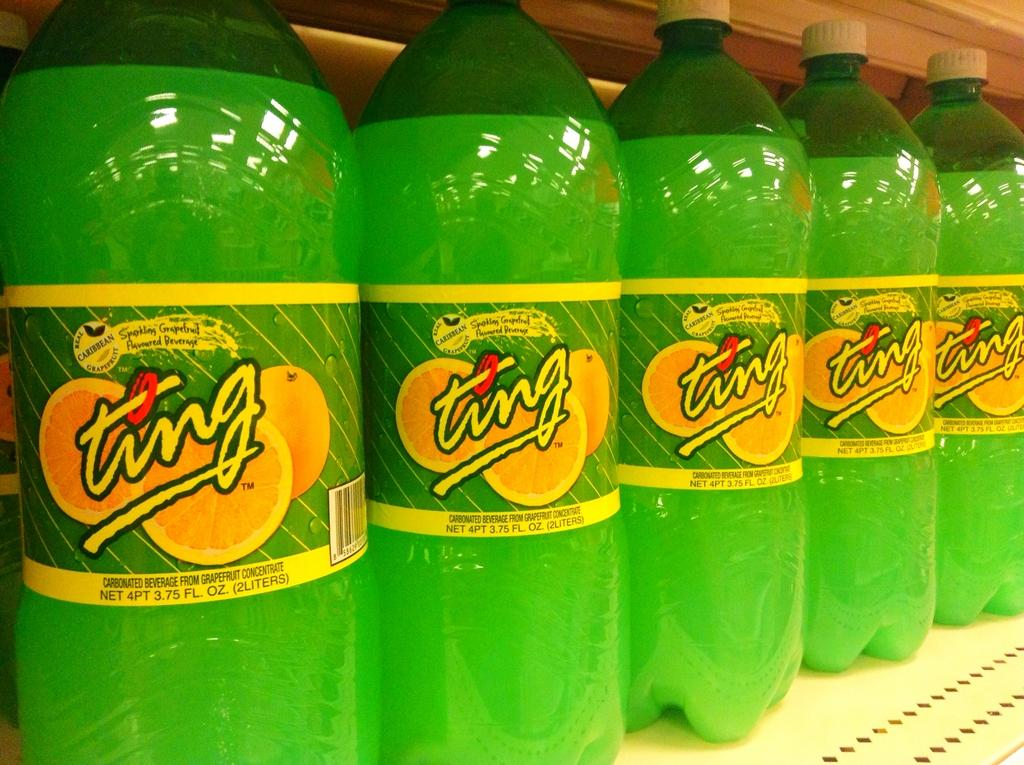How many cool drink bottles are visible in the image? There are five cool drink bottles in the image. How are the cool drink bottles arranged in the image? The cool drink bottles are arranged in a sequence. What type of road can be seen in the image? There is no road present in the image; it only features cool drink bottles arranged in a sequence. 